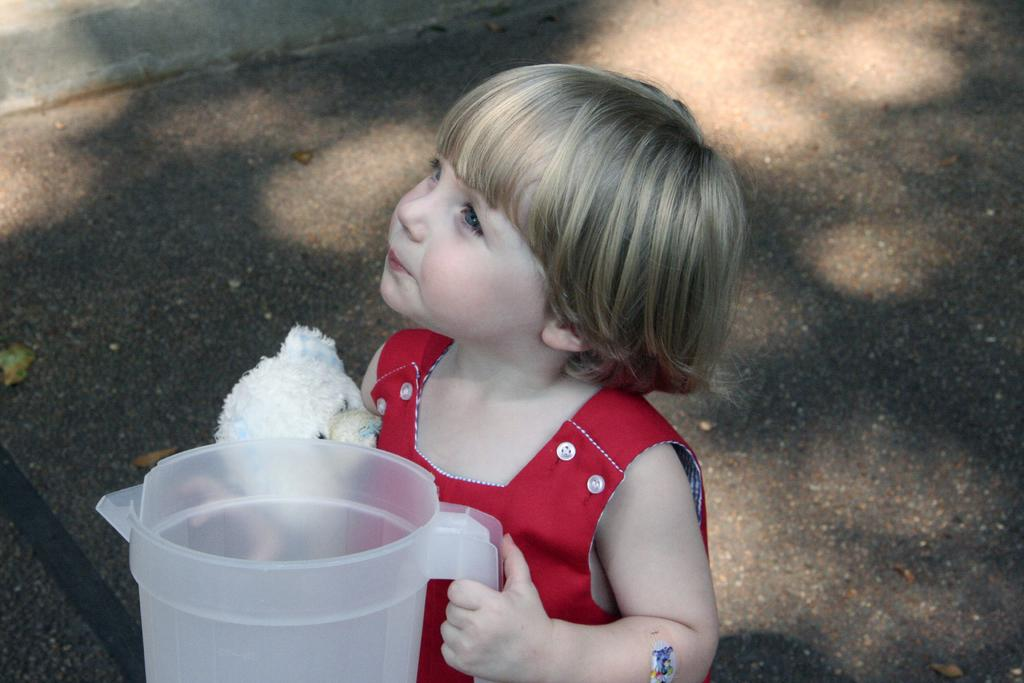Who is the main subject in the picture? There is a girl in the picture. What is the girl holding in her hand? The girl is holding a jar in her hand. What other object can be seen in the picture? There is a teddy bear in the picture. What can be seen in the background of the image? There is a road visible in the background of the image. What type of scissors is the girl using to cut the road in the image? There are no scissors present in the image, and the girl is not cutting the road. 